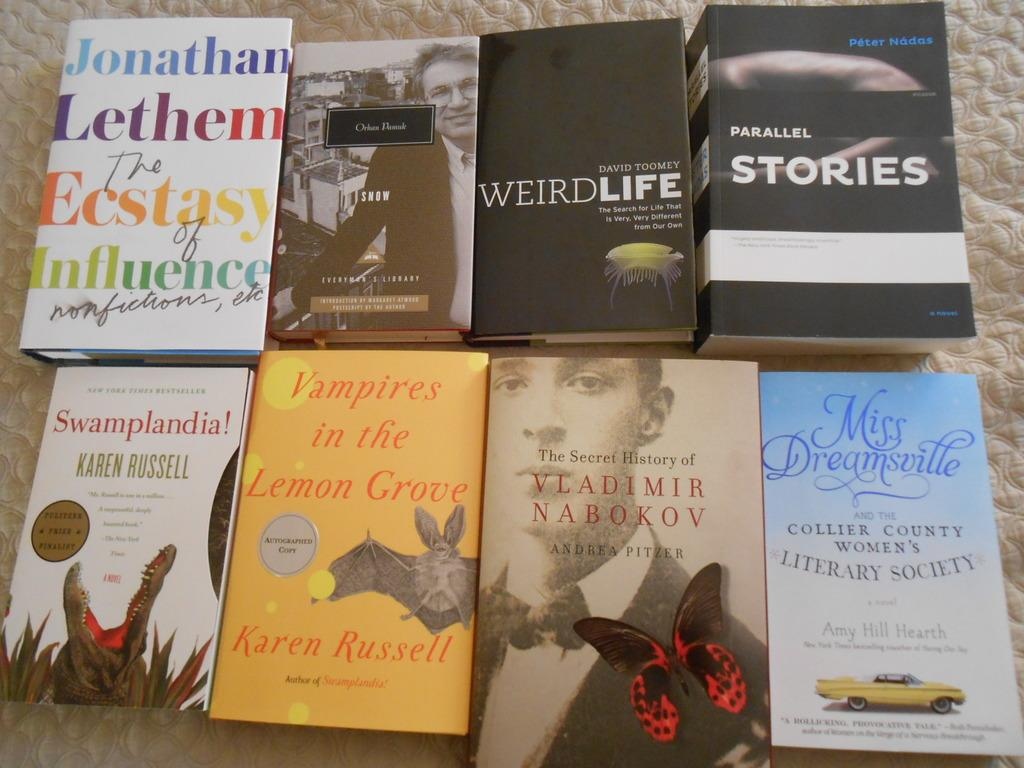<image>
Offer a succinct explanation of the picture presented. books displayed on a white bed spread include Weird Life 